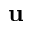<formula> <loc_0><loc_0><loc_500><loc_500>u</formula> 